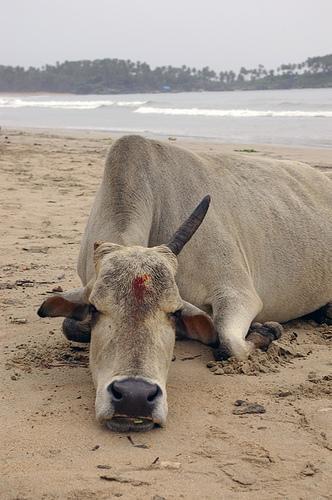How many horns does the cow have?
Give a very brief answer. 1. How many people in this image are dragging a suitcase behind them?
Give a very brief answer. 0. 